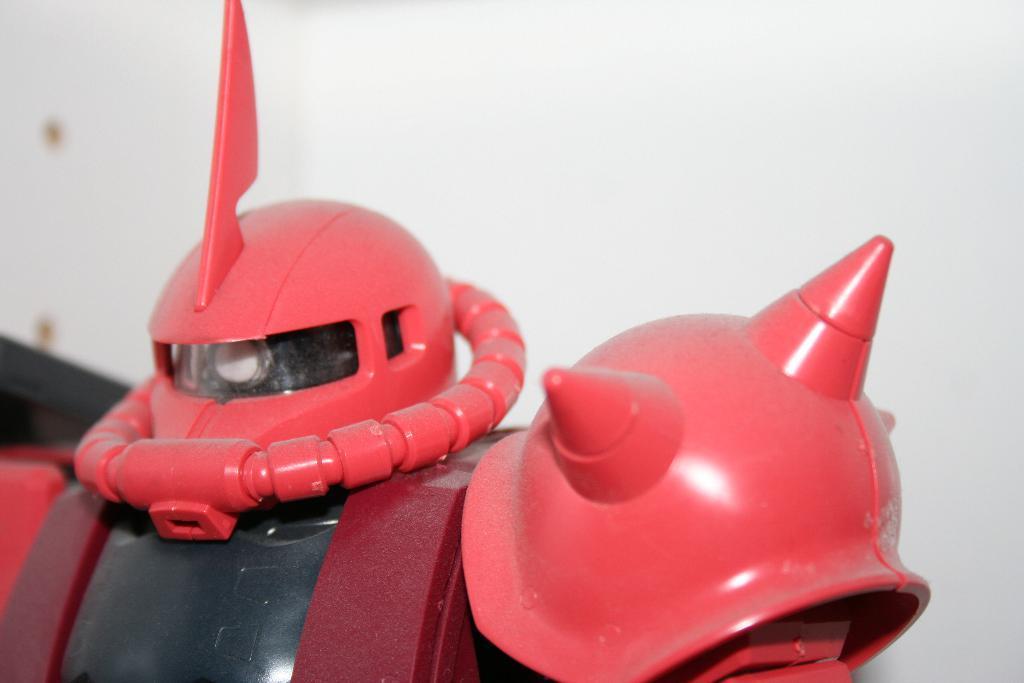How would you summarize this image in a sentence or two? In this image we can see a robot. In the background of the image there is a wall. 